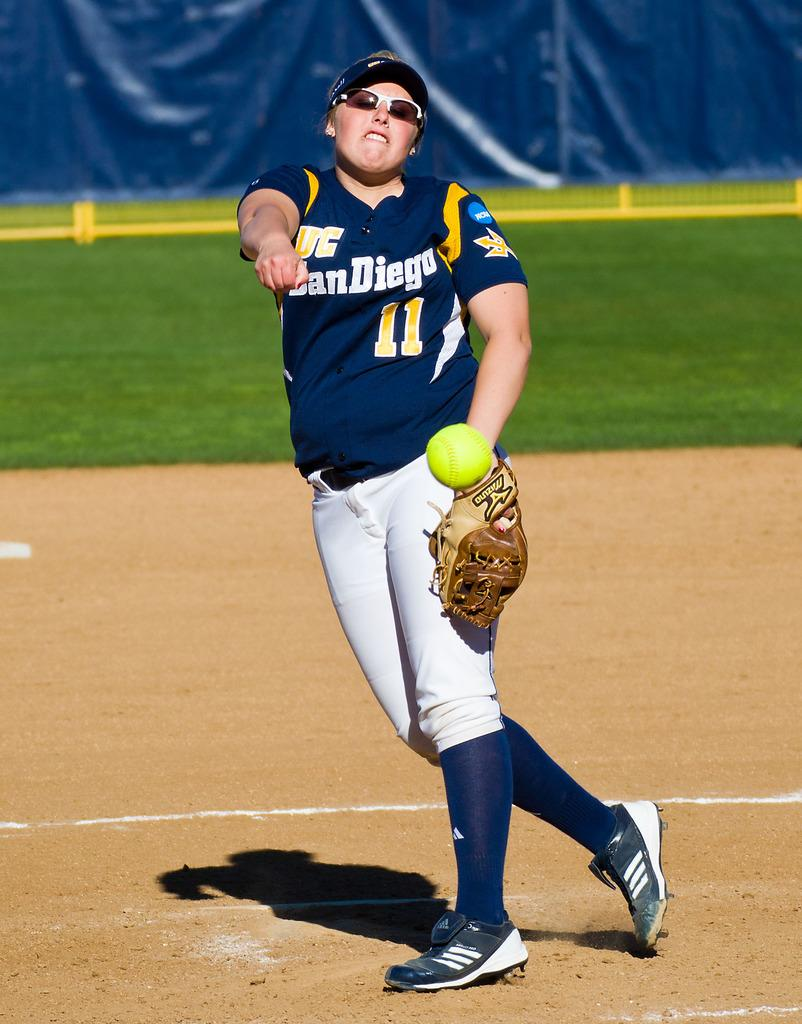Provide a one-sentence caption for the provided image. A softball player from a San Diego team throws a ball. 